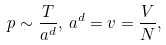Convert formula to latex. <formula><loc_0><loc_0><loc_500><loc_500>p \sim \frac { T } { a ^ { d } } , \, a ^ { d } = v = \frac { V } { N } ,</formula> 